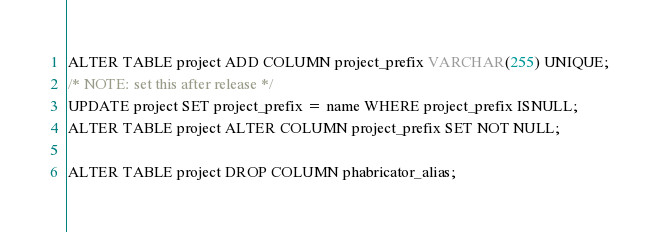<code> <loc_0><loc_0><loc_500><loc_500><_SQL_>ALTER TABLE project ADD COLUMN project_prefix VARCHAR(255) UNIQUE;
/* NOTE: set this after release */
UPDATE project SET project_prefix = name WHERE project_prefix ISNULL;
ALTER TABLE project ALTER COLUMN project_prefix SET NOT NULL;

ALTER TABLE project DROP COLUMN phabricator_alias;
</code> 